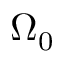<formula> <loc_0><loc_0><loc_500><loc_500>\Omega _ { 0 }</formula> 